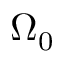<formula> <loc_0><loc_0><loc_500><loc_500>\Omega _ { 0 }</formula> 